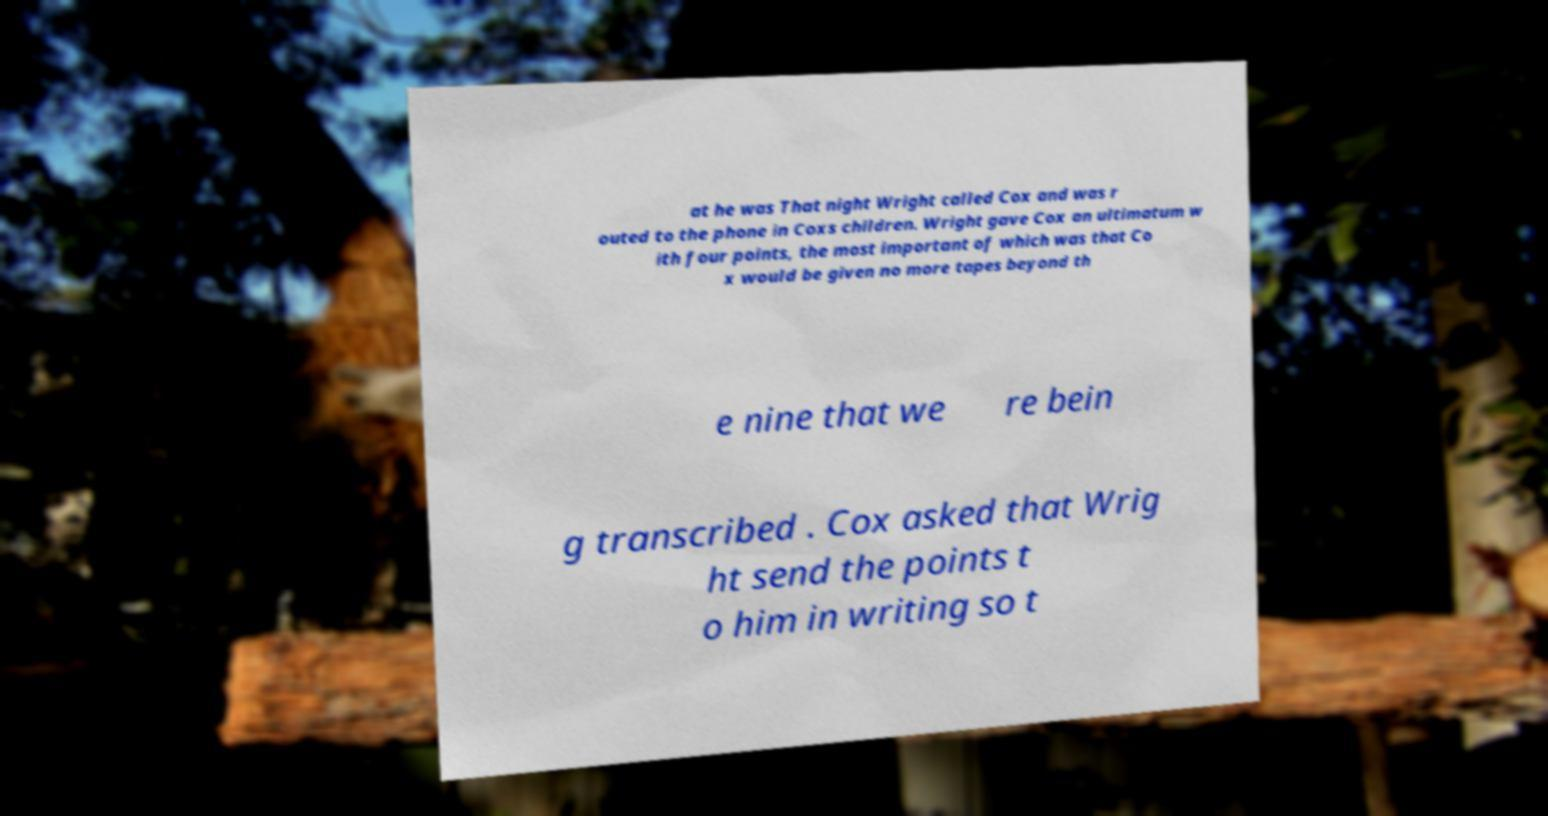I need the written content from this picture converted into text. Can you do that? at he was That night Wright called Cox and was r outed to the phone in Coxs children. Wright gave Cox an ultimatum w ith four points, the most important of which was that Co x would be given no more tapes beyond th e nine that we re bein g transcribed . Cox asked that Wrig ht send the points t o him in writing so t 